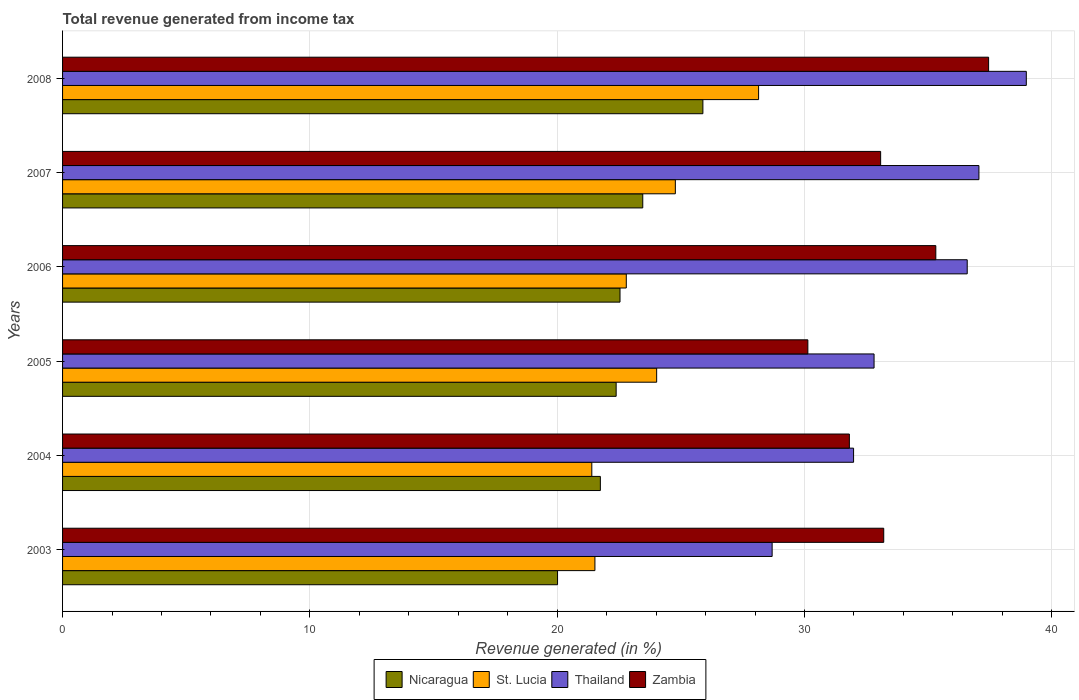How many different coloured bars are there?
Provide a short and direct response. 4. How many groups of bars are there?
Make the answer very short. 6. Are the number of bars per tick equal to the number of legend labels?
Give a very brief answer. Yes. How many bars are there on the 1st tick from the top?
Make the answer very short. 4. How many bars are there on the 6th tick from the bottom?
Provide a succinct answer. 4. What is the label of the 6th group of bars from the top?
Provide a succinct answer. 2003. What is the total revenue generated in St. Lucia in 2004?
Keep it short and to the point. 21.4. Across all years, what is the maximum total revenue generated in Nicaragua?
Provide a succinct answer. 25.89. Across all years, what is the minimum total revenue generated in Thailand?
Provide a short and direct response. 28.69. In which year was the total revenue generated in Zambia minimum?
Keep it short and to the point. 2005. What is the total total revenue generated in Nicaragua in the graph?
Provide a short and direct response. 136.04. What is the difference between the total revenue generated in St. Lucia in 2004 and that in 2008?
Provide a succinct answer. -6.74. What is the difference between the total revenue generated in St. Lucia in 2006 and the total revenue generated in Nicaragua in 2005?
Ensure brevity in your answer.  0.41. What is the average total revenue generated in Thailand per year?
Ensure brevity in your answer.  34.35. In the year 2006, what is the difference between the total revenue generated in Nicaragua and total revenue generated in St. Lucia?
Keep it short and to the point. -0.25. In how many years, is the total revenue generated in Zambia greater than 28 %?
Offer a terse response. 6. What is the ratio of the total revenue generated in Thailand in 2003 to that in 2006?
Offer a terse response. 0.78. What is the difference between the highest and the second highest total revenue generated in Zambia?
Make the answer very short. 2.13. What is the difference between the highest and the lowest total revenue generated in Zambia?
Ensure brevity in your answer.  7.31. Is the sum of the total revenue generated in Zambia in 2005 and 2007 greater than the maximum total revenue generated in St. Lucia across all years?
Keep it short and to the point. Yes. Is it the case that in every year, the sum of the total revenue generated in St. Lucia and total revenue generated in Zambia is greater than the sum of total revenue generated in Nicaragua and total revenue generated in Thailand?
Provide a succinct answer. Yes. What does the 1st bar from the top in 2008 represents?
Offer a very short reply. Zambia. What does the 3rd bar from the bottom in 2008 represents?
Ensure brevity in your answer.  Thailand. Is it the case that in every year, the sum of the total revenue generated in Zambia and total revenue generated in Thailand is greater than the total revenue generated in St. Lucia?
Keep it short and to the point. Yes. How many bars are there?
Provide a succinct answer. 24. What is the difference between two consecutive major ticks on the X-axis?
Make the answer very short. 10. Are the values on the major ticks of X-axis written in scientific E-notation?
Your answer should be very brief. No. Where does the legend appear in the graph?
Give a very brief answer. Bottom center. How many legend labels are there?
Keep it short and to the point. 4. What is the title of the graph?
Keep it short and to the point. Total revenue generated from income tax. Does "Ireland" appear as one of the legend labels in the graph?
Provide a short and direct response. No. What is the label or title of the X-axis?
Offer a terse response. Revenue generated (in %). What is the label or title of the Y-axis?
Provide a short and direct response. Years. What is the Revenue generated (in %) of Nicaragua in 2003?
Make the answer very short. 20.02. What is the Revenue generated (in %) in St. Lucia in 2003?
Offer a terse response. 21.53. What is the Revenue generated (in %) in Thailand in 2003?
Your answer should be compact. 28.69. What is the Revenue generated (in %) of Zambia in 2003?
Your answer should be compact. 33.21. What is the Revenue generated (in %) of Nicaragua in 2004?
Offer a terse response. 21.75. What is the Revenue generated (in %) of St. Lucia in 2004?
Offer a terse response. 21.4. What is the Revenue generated (in %) of Thailand in 2004?
Make the answer very short. 31.99. What is the Revenue generated (in %) of Zambia in 2004?
Give a very brief answer. 31.82. What is the Revenue generated (in %) of Nicaragua in 2005?
Make the answer very short. 22.39. What is the Revenue generated (in %) in St. Lucia in 2005?
Make the answer very short. 24.02. What is the Revenue generated (in %) in Thailand in 2005?
Make the answer very short. 32.81. What is the Revenue generated (in %) in Zambia in 2005?
Offer a terse response. 30.14. What is the Revenue generated (in %) of Nicaragua in 2006?
Keep it short and to the point. 22.54. What is the Revenue generated (in %) of St. Lucia in 2006?
Offer a very short reply. 22.8. What is the Revenue generated (in %) in Thailand in 2006?
Provide a succinct answer. 36.58. What is the Revenue generated (in %) in Zambia in 2006?
Your answer should be very brief. 35.31. What is the Revenue generated (in %) in Nicaragua in 2007?
Your response must be concise. 23.46. What is the Revenue generated (in %) of St. Lucia in 2007?
Make the answer very short. 24.78. What is the Revenue generated (in %) in Thailand in 2007?
Provide a short and direct response. 37.05. What is the Revenue generated (in %) in Zambia in 2007?
Provide a short and direct response. 33.08. What is the Revenue generated (in %) of Nicaragua in 2008?
Your answer should be compact. 25.89. What is the Revenue generated (in %) in St. Lucia in 2008?
Your answer should be compact. 28.15. What is the Revenue generated (in %) in Thailand in 2008?
Give a very brief answer. 38.97. What is the Revenue generated (in %) of Zambia in 2008?
Ensure brevity in your answer.  37.45. Across all years, what is the maximum Revenue generated (in %) in Nicaragua?
Keep it short and to the point. 25.89. Across all years, what is the maximum Revenue generated (in %) in St. Lucia?
Provide a succinct answer. 28.15. Across all years, what is the maximum Revenue generated (in %) of Thailand?
Provide a succinct answer. 38.97. Across all years, what is the maximum Revenue generated (in %) of Zambia?
Your answer should be very brief. 37.45. Across all years, what is the minimum Revenue generated (in %) in Nicaragua?
Provide a succinct answer. 20.02. Across all years, what is the minimum Revenue generated (in %) in St. Lucia?
Ensure brevity in your answer.  21.4. Across all years, what is the minimum Revenue generated (in %) of Thailand?
Keep it short and to the point. 28.69. Across all years, what is the minimum Revenue generated (in %) of Zambia?
Keep it short and to the point. 30.14. What is the total Revenue generated (in %) in Nicaragua in the graph?
Ensure brevity in your answer.  136.04. What is the total Revenue generated (in %) in St. Lucia in the graph?
Offer a terse response. 142.67. What is the total Revenue generated (in %) of Thailand in the graph?
Offer a very short reply. 206.1. What is the total Revenue generated (in %) of Zambia in the graph?
Ensure brevity in your answer.  201. What is the difference between the Revenue generated (in %) of Nicaragua in 2003 and that in 2004?
Ensure brevity in your answer.  -1.73. What is the difference between the Revenue generated (in %) in St. Lucia in 2003 and that in 2004?
Give a very brief answer. 0.13. What is the difference between the Revenue generated (in %) of Thailand in 2003 and that in 2004?
Give a very brief answer. -3.29. What is the difference between the Revenue generated (in %) in Zambia in 2003 and that in 2004?
Your answer should be very brief. 1.39. What is the difference between the Revenue generated (in %) in Nicaragua in 2003 and that in 2005?
Your answer should be very brief. -2.37. What is the difference between the Revenue generated (in %) in St. Lucia in 2003 and that in 2005?
Make the answer very short. -2.5. What is the difference between the Revenue generated (in %) in Thailand in 2003 and that in 2005?
Offer a terse response. -4.12. What is the difference between the Revenue generated (in %) of Zambia in 2003 and that in 2005?
Your answer should be very brief. 3.07. What is the difference between the Revenue generated (in %) in Nicaragua in 2003 and that in 2006?
Give a very brief answer. -2.53. What is the difference between the Revenue generated (in %) of St. Lucia in 2003 and that in 2006?
Your answer should be very brief. -1.27. What is the difference between the Revenue generated (in %) in Thailand in 2003 and that in 2006?
Provide a short and direct response. -7.89. What is the difference between the Revenue generated (in %) in Zambia in 2003 and that in 2006?
Keep it short and to the point. -2.11. What is the difference between the Revenue generated (in %) in Nicaragua in 2003 and that in 2007?
Your answer should be very brief. -3.45. What is the difference between the Revenue generated (in %) of St. Lucia in 2003 and that in 2007?
Your response must be concise. -3.25. What is the difference between the Revenue generated (in %) of Thailand in 2003 and that in 2007?
Provide a succinct answer. -8.36. What is the difference between the Revenue generated (in %) of Zambia in 2003 and that in 2007?
Give a very brief answer. 0.13. What is the difference between the Revenue generated (in %) of Nicaragua in 2003 and that in 2008?
Your answer should be compact. -5.88. What is the difference between the Revenue generated (in %) in St. Lucia in 2003 and that in 2008?
Keep it short and to the point. -6.62. What is the difference between the Revenue generated (in %) in Thailand in 2003 and that in 2008?
Keep it short and to the point. -10.28. What is the difference between the Revenue generated (in %) in Zambia in 2003 and that in 2008?
Give a very brief answer. -4.24. What is the difference between the Revenue generated (in %) in Nicaragua in 2004 and that in 2005?
Your answer should be compact. -0.64. What is the difference between the Revenue generated (in %) of St. Lucia in 2004 and that in 2005?
Offer a terse response. -2.62. What is the difference between the Revenue generated (in %) of Thailand in 2004 and that in 2005?
Make the answer very short. -0.83. What is the difference between the Revenue generated (in %) of Zambia in 2004 and that in 2005?
Offer a very short reply. 1.68. What is the difference between the Revenue generated (in %) of Nicaragua in 2004 and that in 2006?
Make the answer very short. -0.79. What is the difference between the Revenue generated (in %) of St. Lucia in 2004 and that in 2006?
Provide a succinct answer. -1.39. What is the difference between the Revenue generated (in %) of Thailand in 2004 and that in 2006?
Make the answer very short. -4.6. What is the difference between the Revenue generated (in %) of Zambia in 2004 and that in 2006?
Provide a short and direct response. -3.5. What is the difference between the Revenue generated (in %) in Nicaragua in 2004 and that in 2007?
Provide a short and direct response. -1.71. What is the difference between the Revenue generated (in %) of St. Lucia in 2004 and that in 2007?
Your response must be concise. -3.38. What is the difference between the Revenue generated (in %) in Thailand in 2004 and that in 2007?
Provide a short and direct response. -5.07. What is the difference between the Revenue generated (in %) of Zambia in 2004 and that in 2007?
Provide a succinct answer. -1.26. What is the difference between the Revenue generated (in %) of Nicaragua in 2004 and that in 2008?
Offer a very short reply. -4.15. What is the difference between the Revenue generated (in %) of St. Lucia in 2004 and that in 2008?
Keep it short and to the point. -6.74. What is the difference between the Revenue generated (in %) in Thailand in 2004 and that in 2008?
Your answer should be very brief. -6.98. What is the difference between the Revenue generated (in %) in Zambia in 2004 and that in 2008?
Your response must be concise. -5.63. What is the difference between the Revenue generated (in %) in Nicaragua in 2005 and that in 2006?
Give a very brief answer. -0.16. What is the difference between the Revenue generated (in %) of St. Lucia in 2005 and that in 2006?
Make the answer very short. 1.23. What is the difference between the Revenue generated (in %) in Thailand in 2005 and that in 2006?
Provide a short and direct response. -3.77. What is the difference between the Revenue generated (in %) in Zambia in 2005 and that in 2006?
Ensure brevity in your answer.  -5.17. What is the difference between the Revenue generated (in %) of Nicaragua in 2005 and that in 2007?
Provide a short and direct response. -1.08. What is the difference between the Revenue generated (in %) of St. Lucia in 2005 and that in 2007?
Keep it short and to the point. -0.76. What is the difference between the Revenue generated (in %) in Thailand in 2005 and that in 2007?
Make the answer very short. -4.24. What is the difference between the Revenue generated (in %) of Zambia in 2005 and that in 2007?
Ensure brevity in your answer.  -2.94. What is the difference between the Revenue generated (in %) of Nicaragua in 2005 and that in 2008?
Provide a succinct answer. -3.51. What is the difference between the Revenue generated (in %) of St. Lucia in 2005 and that in 2008?
Your answer should be compact. -4.12. What is the difference between the Revenue generated (in %) of Thailand in 2005 and that in 2008?
Your answer should be compact. -6.16. What is the difference between the Revenue generated (in %) in Zambia in 2005 and that in 2008?
Provide a succinct answer. -7.31. What is the difference between the Revenue generated (in %) of Nicaragua in 2006 and that in 2007?
Your response must be concise. -0.92. What is the difference between the Revenue generated (in %) of St. Lucia in 2006 and that in 2007?
Your answer should be very brief. -1.98. What is the difference between the Revenue generated (in %) of Thailand in 2006 and that in 2007?
Offer a terse response. -0.47. What is the difference between the Revenue generated (in %) of Zambia in 2006 and that in 2007?
Ensure brevity in your answer.  2.23. What is the difference between the Revenue generated (in %) in Nicaragua in 2006 and that in 2008?
Provide a short and direct response. -3.35. What is the difference between the Revenue generated (in %) in St. Lucia in 2006 and that in 2008?
Give a very brief answer. -5.35. What is the difference between the Revenue generated (in %) in Thailand in 2006 and that in 2008?
Provide a short and direct response. -2.39. What is the difference between the Revenue generated (in %) in Zambia in 2006 and that in 2008?
Provide a succinct answer. -2.13. What is the difference between the Revenue generated (in %) in Nicaragua in 2007 and that in 2008?
Provide a succinct answer. -2.43. What is the difference between the Revenue generated (in %) of St. Lucia in 2007 and that in 2008?
Make the answer very short. -3.37. What is the difference between the Revenue generated (in %) of Thailand in 2007 and that in 2008?
Offer a very short reply. -1.92. What is the difference between the Revenue generated (in %) in Zambia in 2007 and that in 2008?
Your answer should be compact. -4.37. What is the difference between the Revenue generated (in %) of Nicaragua in 2003 and the Revenue generated (in %) of St. Lucia in 2004?
Provide a succinct answer. -1.39. What is the difference between the Revenue generated (in %) of Nicaragua in 2003 and the Revenue generated (in %) of Thailand in 2004?
Provide a succinct answer. -11.97. What is the difference between the Revenue generated (in %) of Nicaragua in 2003 and the Revenue generated (in %) of Zambia in 2004?
Ensure brevity in your answer.  -11.8. What is the difference between the Revenue generated (in %) in St. Lucia in 2003 and the Revenue generated (in %) in Thailand in 2004?
Your answer should be compact. -10.46. What is the difference between the Revenue generated (in %) of St. Lucia in 2003 and the Revenue generated (in %) of Zambia in 2004?
Your answer should be compact. -10.29. What is the difference between the Revenue generated (in %) of Thailand in 2003 and the Revenue generated (in %) of Zambia in 2004?
Your response must be concise. -3.12. What is the difference between the Revenue generated (in %) of Nicaragua in 2003 and the Revenue generated (in %) of St. Lucia in 2005?
Give a very brief answer. -4.01. What is the difference between the Revenue generated (in %) in Nicaragua in 2003 and the Revenue generated (in %) in Thailand in 2005?
Offer a very short reply. -12.8. What is the difference between the Revenue generated (in %) in Nicaragua in 2003 and the Revenue generated (in %) in Zambia in 2005?
Offer a terse response. -10.12. What is the difference between the Revenue generated (in %) in St. Lucia in 2003 and the Revenue generated (in %) in Thailand in 2005?
Your answer should be compact. -11.29. What is the difference between the Revenue generated (in %) of St. Lucia in 2003 and the Revenue generated (in %) of Zambia in 2005?
Your response must be concise. -8.61. What is the difference between the Revenue generated (in %) of Thailand in 2003 and the Revenue generated (in %) of Zambia in 2005?
Provide a succinct answer. -1.44. What is the difference between the Revenue generated (in %) in Nicaragua in 2003 and the Revenue generated (in %) in St. Lucia in 2006?
Provide a succinct answer. -2.78. What is the difference between the Revenue generated (in %) of Nicaragua in 2003 and the Revenue generated (in %) of Thailand in 2006?
Your response must be concise. -16.57. What is the difference between the Revenue generated (in %) of Nicaragua in 2003 and the Revenue generated (in %) of Zambia in 2006?
Ensure brevity in your answer.  -15.3. What is the difference between the Revenue generated (in %) of St. Lucia in 2003 and the Revenue generated (in %) of Thailand in 2006?
Ensure brevity in your answer.  -15.06. What is the difference between the Revenue generated (in %) of St. Lucia in 2003 and the Revenue generated (in %) of Zambia in 2006?
Keep it short and to the point. -13.79. What is the difference between the Revenue generated (in %) in Thailand in 2003 and the Revenue generated (in %) in Zambia in 2006?
Offer a terse response. -6.62. What is the difference between the Revenue generated (in %) in Nicaragua in 2003 and the Revenue generated (in %) in St. Lucia in 2007?
Provide a short and direct response. -4.76. What is the difference between the Revenue generated (in %) in Nicaragua in 2003 and the Revenue generated (in %) in Thailand in 2007?
Ensure brevity in your answer.  -17.04. What is the difference between the Revenue generated (in %) of Nicaragua in 2003 and the Revenue generated (in %) of Zambia in 2007?
Ensure brevity in your answer.  -13.07. What is the difference between the Revenue generated (in %) of St. Lucia in 2003 and the Revenue generated (in %) of Thailand in 2007?
Give a very brief answer. -15.53. What is the difference between the Revenue generated (in %) in St. Lucia in 2003 and the Revenue generated (in %) in Zambia in 2007?
Offer a very short reply. -11.55. What is the difference between the Revenue generated (in %) of Thailand in 2003 and the Revenue generated (in %) of Zambia in 2007?
Your response must be concise. -4.39. What is the difference between the Revenue generated (in %) of Nicaragua in 2003 and the Revenue generated (in %) of St. Lucia in 2008?
Ensure brevity in your answer.  -8.13. What is the difference between the Revenue generated (in %) of Nicaragua in 2003 and the Revenue generated (in %) of Thailand in 2008?
Offer a terse response. -18.96. What is the difference between the Revenue generated (in %) in Nicaragua in 2003 and the Revenue generated (in %) in Zambia in 2008?
Offer a terse response. -17.43. What is the difference between the Revenue generated (in %) of St. Lucia in 2003 and the Revenue generated (in %) of Thailand in 2008?
Your response must be concise. -17.44. What is the difference between the Revenue generated (in %) in St. Lucia in 2003 and the Revenue generated (in %) in Zambia in 2008?
Your answer should be very brief. -15.92. What is the difference between the Revenue generated (in %) of Thailand in 2003 and the Revenue generated (in %) of Zambia in 2008?
Provide a short and direct response. -8.75. What is the difference between the Revenue generated (in %) in Nicaragua in 2004 and the Revenue generated (in %) in St. Lucia in 2005?
Your answer should be compact. -2.28. What is the difference between the Revenue generated (in %) in Nicaragua in 2004 and the Revenue generated (in %) in Thailand in 2005?
Your answer should be very brief. -11.07. What is the difference between the Revenue generated (in %) of Nicaragua in 2004 and the Revenue generated (in %) of Zambia in 2005?
Offer a very short reply. -8.39. What is the difference between the Revenue generated (in %) of St. Lucia in 2004 and the Revenue generated (in %) of Thailand in 2005?
Provide a succinct answer. -11.41. What is the difference between the Revenue generated (in %) in St. Lucia in 2004 and the Revenue generated (in %) in Zambia in 2005?
Give a very brief answer. -8.74. What is the difference between the Revenue generated (in %) of Thailand in 2004 and the Revenue generated (in %) of Zambia in 2005?
Provide a succinct answer. 1.85. What is the difference between the Revenue generated (in %) of Nicaragua in 2004 and the Revenue generated (in %) of St. Lucia in 2006?
Keep it short and to the point. -1.05. What is the difference between the Revenue generated (in %) of Nicaragua in 2004 and the Revenue generated (in %) of Thailand in 2006?
Offer a very short reply. -14.83. What is the difference between the Revenue generated (in %) of Nicaragua in 2004 and the Revenue generated (in %) of Zambia in 2006?
Offer a terse response. -13.56. What is the difference between the Revenue generated (in %) in St. Lucia in 2004 and the Revenue generated (in %) in Thailand in 2006?
Your answer should be compact. -15.18. What is the difference between the Revenue generated (in %) of St. Lucia in 2004 and the Revenue generated (in %) of Zambia in 2006?
Your answer should be compact. -13.91. What is the difference between the Revenue generated (in %) in Thailand in 2004 and the Revenue generated (in %) in Zambia in 2006?
Your response must be concise. -3.33. What is the difference between the Revenue generated (in %) of Nicaragua in 2004 and the Revenue generated (in %) of St. Lucia in 2007?
Give a very brief answer. -3.03. What is the difference between the Revenue generated (in %) of Nicaragua in 2004 and the Revenue generated (in %) of Thailand in 2007?
Offer a terse response. -15.31. What is the difference between the Revenue generated (in %) of Nicaragua in 2004 and the Revenue generated (in %) of Zambia in 2007?
Ensure brevity in your answer.  -11.33. What is the difference between the Revenue generated (in %) of St. Lucia in 2004 and the Revenue generated (in %) of Thailand in 2007?
Your answer should be compact. -15.65. What is the difference between the Revenue generated (in %) in St. Lucia in 2004 and the Revenue generated (in %) in Zambia in 2007?
Provide a short and direct response. -11.68. What is the difference between the Revenue generated (in %) in Thailand in 2004 and the Revenue generated (in %) in Zambia in 2007?
Your response must be concise. -1.09. What is the difference between the Revenue generated (in %) of Nicaragua in 2004 and the Revenue generated (in %) of St. Lucia in 2008?
Ensure brevity in your answer.  -6.4. What is the difference between the Revenue generated (in %) in Nicaragua in 2004 and the Revenue generated (in %) in Thailand in 2008?
Your response must be concise. -17.22. What is the difference between the Revenue generated (in %) of Nicaragua in 2004 and the Revenue generated (in %) of Zambia in 2008?
Your answer should be compact. -15.7. What is the difference between the Revenue generated (in %) of St. Lucia in 2004 and the Revenue generated (in %) of Thailand in 2008?
Offer a very short reply. -17.57. What is the difference between the Revenue generated (in %) of St. Lucia in 2004 and the Revenue generated (in %) of Zambia in 2008?
Ensure brevity in your answer.  -16.05. What is the difference between the Revenue generated (in %) in Thailand in 2004 and the Revenue generated (in %) in Zambia in 2008?
Give a very brief answer. -5.46. What is the difference between the Revenue generated (in %) in Nicaragua in 2005 and the Revenue generated (in %) in St. Lucia in 2006?
Your answer should be very brief. -0.41. What is the difference between the Revenue generated (in %) of Nicaragua in 2005 and the Revenue generated (in %) of Thailand in 2006?
Provide a short and direct response. -14.2. What is the difference between the Revenue generated (in %) in Nicaragua in 2005 and the Revenue generated (in %) in Zambia in 2006?
Make the answer very short. -12.93. What is the difference between the Revenue generated (in %) of St. Lucia in 2005 and the Revenue generated (in %) of Thailand in 2006?
Your answer should be very brief. -12.56. What is the difference between the Revenue generated (in %) in St. Lucia in 2005 and the Revenue generated (in %) in Zambia in 2006?
Ensure brevity in your answer.  -11.29. What is the difference between the Revenue generated (in %) in Thailand in 2005 and the Revenue generated (in %) in Zambia in 2006?
Give a very brief answer. -2.5. What is the difference between the Revenue generated (in %) in Nicaragua in 2005 and the Revenue generated (in %) in St. Lucia in 2007?
Your answer should be compact. -2.39. What is the difference between the Revenue generated (in %) in Nicaragua in 2005 and the Revenue generated (in %) in Thailand in 2007?
Your response must be concise. -14.67. What is the difference between the Revenue generated (in %) in Nicaragua in 2005 and the Revenue generated (in %) in Zambia in 2007?
Your answer should be very brief. -10.7. What is the difference between the Revenue generated (in %) in St. Lucia in 2005 and the Revenue generated (in %) in Thailand in 2007?
Ensure brevity in your answer.  -13.03. What is the difference between the Revenue generated (in %) in St. Lucia in 2005 and the Revenue generated (in %) in Zambia in 2007?
Your answer should be compact. -9.06. What is the difference between the Revenue generated (in %) in Thailand in 2005 and the Revenue generated (in %) in Zambia in 2007?
Give a very brief answer. -0.27. What is the difference between the Revenue generated (in %) in Nicaragua in 2005 and the Revenue generated (in %) in St. Lucia in 2008?
Your answer should be compact. -5.76. What is the difference between the Revenue generated (in %) in Nicaragua in 2005 and the Revenue generated (in %) in Thailand in 2008?
Give a very brief answer. -16.59. What is the difference between the Revenue generated (in %) of Nicaragua in 2005 and the Revenue generated (in %) of Zambia in 2008?
Provide a succinct answer. -15.06. What is the difference between the Revenue generated (in %) in St. Lucia in 2005 and the Revenue generated (in %) in Thailand in 2008?
Provide a short and direct response. -14.95. What is the difference between the Revenue generated (in %) of St. Lucia in 2005 and the Revenue generated (in %) of Zambia in 2008?
Offer a very short reply. -13.42. What is the difference between the Revenue generated (in %) of Thailand in 2005 and the Revenue generated (in %) of Zambia in 2008?
Make the answer very short. -4.63. What is the difference between the Revenue generated (in %) of Nicaragua in 2006 and the Revenue generated (in %) of St. Lucia in 2007?
Give a very brief answer. -2.24. What is the difference between the Revenue generated (in %) of Nicaragua in 2006 and the Revenue generated (in %) of Thailand in 2007?
Provide a short and direct response. -14.51. What is the difference between the Revenue generated (in %) in Nicaragua in 2006 and the Revenue generated (in %) in Zambia in 2007?
Your answer should be very brief. -10.54. What is the difference between the Revenue generated (in %) of St. Lucia in 2006 and the Revenue generated (in %) of Thailand in 2007?
Offer a terse response. -14.26. What is the difference between the Revenue generated (in %) of St. Lucia in 2006 and the Revenue generated (in %) of Zambia in 2007?
Your response must be concise. -10.28. What is the difference between the Revenue generated (in %) of Thailand in 2006 and the Revenue generated (in %) of Zambia in 2007?
Provide a short and direct response. 3.5. What is the difference between the Revenue generated (in %) of Nicaragua in 2006 and the Revenue generated (in %) of St. Lucia in 2008?
Your response must be concise. -5.6. What is the difference between the Revenue generated (in %) of Nicaragua in 2006 and the Revenue generated (in %) of Thailand in 2008?
Offer a very short reply. -16.43. What is the difference between the Revenue generated (in %) of Nicaragua in 2006 and the Revenue generated (in %) of Zambia in 2008?
Your answer should be compact. -14.9. What is the difference between the Revenue generated (in %) in St. Lucia in 2006 and the Revenue generated (in %) in Thailand in 2008?
Provide a short and direct response. -16.18. What is the difference between the Revenue generated (in %) of St. Lucia in 2006 and the Revenue generated (in %) of Zambia in 2008?
Offer a terse response. -14.65. What is the difference between the Revenue generated (in %) in Thailand in 2006 and the Revenue generated (in %) in Zambia in 2008?
Offer a terse response. -0.86. What is the difference between the Revenue generated (in %) in Nicaragua in 2007 and the Revenue generated (in %) in St. Lucia in 2008?
Your answer should be very brief. -4.68. What is the difference between the Revenue generated (in %) in Nicaragua in 2007 and the Revenue generated (in %) in Thailand in 2008?
Make the answer very short. -15.51. What is the difference between the Revenue generated (in %) of Nicaragua in 2007 and the Revenue generated (in %) of Zambia in 2008?
Provide a short and direct response. -13.98. What is the difference between the Revenue generated (in %) of St. Lucia in 2007 and the Revenue generated (in %) of Thailand in 2008?
Give a very brief answer. -14.19. What is the difference between the Revenue generated (in %) in St. Lucia in 2007 and the Revenue generated (in %) in Zambia in 2008?
Make the answer very short. -12.67. What is the difference between the Revenue generated (in %) in Thailand in 2007 and the Revenue generated (in %) in Zambia in 2008?
Give a very brief answer. -0.39. What is the average Revenue generated (in %) of Nicaragua per year?
Provide a short and direct response. 22.67. What is the average Revenue generated (in %) of St. Lucia per year?
Provide a succinct answer. 23.78. What is the average Revenue generated (in %) in Thailand per year?
Offer a terse response. 34.35. What is the average Revenue generated (in %) of Zambia per year?
Keep it short and to the point. 33.5. In the year 2003, what is the difference between the Revenue generated (in %) of Nicaragua and Revenue generated (in %) of St. Lucia?
Your answer should be very brief. -1.51. In the year 2003, what is the difference between the Revenue generated (in %) in Nicaragua and Revenue generated (in %) in Thailand?
Provide a short and direct response. -8.68. In the year 2003, what is the difference between the Revenue generated (in %) in Nicaragua and Revenue generated (in %) in Zambia?
Provide a succinct answer. -13.19. In the year 2003, what is the difference between the Revenue generated (in %) in St. Lucia and Revenue generated (in %) in Thailand?
Your answer should be very brief. -7.17. In the year 2003, what is the difference between the Revenue generated (in %) of St. Lucia and Revenue generated (in %) of Zambia?
Your answer should be compact. -11.68. In the year 2003, what is the difference between the Revenue generated (in %) of Thailand and Revenue generated (in %) of Zambia?
Give a very brief answer. -4.51. In the year 2004, what is the difference between the Revenue generated (in %) in Nicaragua and Revenue generated (in %) in St. Lucia?
Make the answer very short. 0.35. In the year 2004, what is the difference between the Revenue generated (in %) in Nicaragua and Revenue generated (in %) in Thailand?
Offer a terse response. -10.24. In the year 2004, what is the difference between the Revenue generated (in %) of Nicaragua and Revenue generated (in %) of Zambia?
Keep it short and to the point. -10.07. In the year 2004, what is the difference between the Revenue generated (in %) in St. Lucia and Revenue generated (in %) in Thailand?
Your answer should be very brief. -10.59. In the year 2004, what is the difference between the Revenue generated (in %) in St. Lucia and Revenue generated (in %) in Zambia?
Provide a succinct answer. -10.42. In the year 2004, what is the difference between the Revenue generated (in %) in Thailand and Revenue generated (in %) in Zambia?
Your answer should be compact. 0.17. In the year 2005, what is the difference between the Revenue generated (in %) of Nicaragua and Revenue generated (in %) of St. Lucia?
Keep it short and to the point. -1.64. In the year 2005, what is the difference between the Revenue generated (in %) in Nicaragua and Revenue generated (in %) in Thailand?
Your answer should be compact. -10.43. In the year 2005, what is the difference between the Revenue generated (in %) in Nicaragua and Revenue generated (in %) in Zambia?
Make the answer very short. -7.75. In the year 2005, what is the difference between the Revenue generated (in %) of St. Lucia and Revenue generated (in %) of Thailand?
Ensure brevity in your answer.  -8.79. In the year 2005, what is the difference between the Revenue generated (in %) of St. Lucia and Revenue generated (in %) of Zambia?
Keep it short and to the point. -6.11. In the year 2005, what is the difference between the Revenue generated (in %) in Thailand and Revenue generated (in %) in Zambia?
Your answer should be very brief. 2.68. In the year 2006, what is the difference between the Revenue generated (in %) in Nicaragua and Revenue generated (in %) in St. Lucia?
Give a very brief answer. -0.25. In the year 2006, what is the difference between the Revenue generated (in %) of Nicaragua and Revenue generated (in %) of Thailand?
Provide a succinct answer. -14.04. In the year 2006, what is the difference between the Revenue generated (in %) in Nicaragua and Revenue generated (in %) in Zambia?
Offer a terse response. -12.77. In the year 2006, what is the difference between the Revenue generated (in %) in St. Lucia and Revenue generated (in %) in Thailand?
Your answer should be compact. -13.79. In the year 2006, what is the difference between the Revenue generated (in %) of St. Lucia and Revenue generated (in %) of Zambia?
Offer a very short reply. -12.52. In the year 2006, what is the difference between the Revenue generated (in %) in Thailand and Revenue generated (in %) in Zambia?
Your answer should be compact. 1.27. In the year 2007, what is the difference between the Revenue generated (in %) of Nicaragua and Revenue generated (in %) of St. Lucia?
Give a very brief answer. -1.32. In the year 2007, what is the difference between the Revenue generated (in %) of Nicaragua and Revenue generated (in %) of Thailand?
Keep it short and to the point. -13.59. In the year 2007, what is the difference between the Revenue generated (in %) of Nicaragua and Revenue generated (in %) of Zambia?
Your response must be concise. -9.62. In the year 2007, what is the difference between the Revenue generated (in %) of St. Lucia and Revenue generated (in %) of Thailand?
Make the answer very short. -12.28. In the year 2007, what is the difference between the Revenue generated (in %) in St. Lucia and Revenue generated (in %) in Zambia?
Your answer should be compact. -8.3. In the year 2007, what is the difference between the Revenue generated (in %) in Thailand and Revenue generated (in %) in Zambia?
Make the answer very short. 3.97. In the year 2008, what is the difference between the Revenue generated (in %) in Nicaragua and Revenue generated (in %) in St. Lucia?
Your answer should be compact. -2.25. In the year 2008, what is the difference between the Revenue generated (in %) of Nicaragua and Revenue generated (in %) of Thailand?
Make the answer very short. -13.08. In the year 2008, what is the difference between the Revenue generated (in %) in Nicaragua and Revenue generated (in %) in Zambia?
Make the answer very short. -11.55. In the year 2008, what is the difference between the Revenue generated (in %) of St. Lucia and Revenue generated (in %) of Thailand?
Keep it short and to the point. -10.83. In the year 2008, what is the difference between the Revenue generated (in %) in St. Lucia and Revenue generated (in %) in Zambia?
Provide a succinct answer. -9.3. In the year 2008, what is the difference between the Revenue generated (in %) of Thailand and Revenue generated (in %) of Zambia?
Your answer should be compact. 1.52. What is the ratio of the Revenue generated (in %) of Nicaragua in 2003 to that in 2004?
Provide a short and direct response. 0.92. What is the ratio of the Revenue generated (in %) of St. Lucia in 2003 to that in 2004?
Your answer should be compact. 1.01. What is the ratio of the Revenue generated (in %) in Thailand in 2003 to that in 2004?
Your response must be concise. 0.9. What is the ratio of the Revenue generated (in %) of Zambia in 2003 to that in 2004?
Keep it short and to the point. 1.04. What is the ratio of the Revenue generated (in %) of Nicaragua in 2003 to that in 2005?
Give a very brief answer. 0.89. What is the ratio of the Revenue generated (in %) in St. Lucia in 2003 to that in 2005?
Ensure brevity in your answer.  0.9. What is the ratio of the Revenue generated (in %) in Thailand in 2003 to that in 2005?
Ensure brevity in your answer.  0.87. What is the ratio of the Revenue generated (in %) of Zambia in 2003 to that in 2005?
Your answer should be compact. 1.1. What is the ratio of the Revenue generated (in %) in Nicaragua in 2003 to that in 2006?
Offer a very short reply. 0.89. What is the ratio of the Revenue generated (in %) in St. Lucia in 2003 to that in 2006?
Offer a terse response. 0.94. What is the ratio of the Revenue generated (in %) in Thailand in 2003 to that in 2006?
Your answer should be compact. 0.78. What is the ratio of the Revenue generated (in %) of Zambia in 2003 to that in 2006?
Your response must be concise. 0.94. What is the ratio of the Revenue generated (in %) in Nicaragua in 2003 to that in 2007?
Offer a terse response. 0.85. What is the ratio of the Revenue generated (in %) in St. Lucia in 2003 to that in 2007?
Offer a terse response. 0.87. What is the ratio of the Revenue generated (in %) of Thailand in 2003 to that in 2007?
Offer a very short reply. 0.77. What is the ratio of the Revenue generated (in %) in Nicaragua in 2003 to that in 2008?
Offer a terse response. 0.77. What is the ratio of the Revenue generated (in %) in St. Lucia in 2003 to that in 2008?
Give a very brief answer. 0.76. What is the ratio of the Revenue generated (in %) in Thailand in 2003 to that in 2008?
Your response must be concise. 0.74. What is the ratio of the Revenue generated (in %) of Zambia in 2003 to that in 2008?
Your answer should be compact. 0.89. What is the ratio of the Revenue generated (in %) in Nicaragua in 2004 to that in 2005?
Offer a terse response. 0.97. What is the ratio of the Revenue generated (in %) of St. Lucia in 2004 to that in 2005?
Offer a very short reply. 0.89. What is the ratio of the Revenue generated (in %) in Thailand in 2004 to that in 2005?
Your answer should be compact. 0.97. What is the ratio of the Revenue generated (in %) of Zambia in 2004 to that in 2005?
Make the answer very short. 1.06. What is the ratio of the Revenue generated (in %) in Nicaragua in 2004 to that in 2006?
Your answer should be very brief. 0.96. What is the ratio of the Revenue generated (in %) in St. Lucia in 2004 to that in 2006?
Make the answer very short. 0.94. What is the ratio of the Revenue generated (in %) of Thailand in 2004 to that in 2006?
Ensure brevity in your answer.  0.87. What is the ratio of the Revenue generated (in %) in Zambia in 2004 to that in 2006?
Provide a succinct answer. 0.9. What is the ratio of the Revenue generated (in %) of Nicaragua in 2004 to that in 2007?
Provide a short and direct response. 0.93. What is the ratio of the Revenue generated (in %) of St. Lucia in 2004 to that in 2007?
Your answer should be compact. 0.86. What is the ratio of the Revenue generated (in %) of Thailand in 2004 to that in 2007?
Your answer should be very brief. 0.86. What is the ratio of the Revenue generated (in %) of Zambia in 2004 to that in 2007?
Your answer should be very brief. 0.96. What is the ratio of the Revenue generated (in %) in Nicaragua in 2004 to that in 2008?
Offer a terse response. 0.84. What is the ratio of the Revenue generated (in %) in St. Lucia in 2004 to that in 2008?
Offer a terse response. 0.76. What is the ratio of the Revenue generated (in %) in Thailand in 2004 to that in 2008?
Your answer should be very brief. 0.82. What is the ratio of the Revenue generated (in %) in Zambia in 2004 to that in 2008?
Offer a terse response. 0.85. What is the ratio of the Revenue generated (in %) in Nicaragua in 2005 to that in 2006?
Offer a terse response. 0.99. What is the ratio of the Revenue generated (in %) of St. Lucia in 2005 to that in 2006?
Your answer should be compact. 1.05. What is the ratio of the Revenue generated (in %) in Thailand in 2005 to that in 2006?
Your answer should be very brief. 0.9. What is the ratio of the Revenue generated (in %) in Zambia in 2005 to that in 2006?
Provide a short and direct response. 0.85. What is the ratio of the Revenue generated (in %) of Nicaragua in 2005 to that in 2007?
Provide a short and direct response. 0.95. What is the ratio of the Revenue generated (in %) in St. Lucia in 2005 to that in 2007?
Your answer should be compact. 0.97. What is the ratio of the Revenue generated (in %) in Thailand in 2005 to that in 2007?
Give a very brief answer. 0.89. What is the ratio of the Revenue generated (in %) of Zambia in 2005 to that in 2007?
Offer a terse response. 0.91. What is the ratio of the Revenue generated (in %) of Nicaragua in 2005 to that in 2008?
Your answer should be very brief. 0.86. What is the ratio of the Revenue generated (in %) of St. Lucia in 2005 to that in 2008?
Ensure brevity in your answer.  0.85. What is the ratio of the Revenue generated (in %) in Thailand in 2005 to that in 2008?
Give a very brief answer. 0.84. What is the ratio of the Revenue generated (in %) in Zambia in 2005 to that in 2008?
Ensure brevity in your answer.  0.8. What is the ratio of the Revenue generated (in %) of Nicaragua in 2006 to that in 2007?
Provide a short and direct response. 0.96. What is the ratio of the Revenue generated (in %) of St. Lucia in 2006 to that in 2007?
Your answer should be very brief. 0.92. What is the ratio of the Revenue generated (in %) in Thailand in 2006 to that in 2007?
Your answer should be compact. 0.99. What is the ratio of the Revenue generated (in %) of Zambia in 2006 to that in 2007?
Offer a very short reply. 1.07. What is the ratio of the Revenue generated (in %) in Nicaragua in 2006 to that in 2008?
Offer a very short reply. 0.87. What is the ratio of the Revenue generated (in %) of St. Lucia in 2006 to that in 2008?
Offer a terse response. 0.81. What is the ratio of the Revenue generated (in %) of Thailand in 2006 to that in 2008?
Keep it short and to the point. 0.94. What is the ratio of the Revenue generated (in %) of Zambia in 2006 to that in 2008?
Provide a short and direct response. 0.94. What is the ratio of the Revenue generated (in %) in Nicaragua in 2007 to that in 2008?
Keep it short and to the point. 0.91. What is the ratio of the Revenue generated (in %) in St. Lucia in 2007 to that in 2008?
Provide a short and direct response. 0.88. What is the ratio of the Revenue generated (in %) of Thailand in 2007 to that in 2008?
Make the answer very short. 0.95. What is the ratio of the Revenue generated (in %) of Zambia in 2007 to that in 2008?
Offer a very short reply. 0.88. What is the difference between the highest and the second highest Revenue generated (in %) in Nicaragua?
Give a very brief answer. 2.43. What is the difference between the highest and the second highest Revenue generated (in %) of St. Lucia?
Ensure brevity in your answer.  3.37. What is the difference between the highest and the second highest Revenue generated (in %) in Thailand?
Your response must be concise. 1.92. What is the difference between the highest and the second highest Revenue generated (in %) in Zambia?
Keep it short and to the point. 2.13. What is the difference between the highest and the lowest Revenue generated (in %) of Nicaragua?
Your response must be concise. 5.88. What is the difference between the highest and the lowest Revenue generated (in %) in St. Lucia?
Make the answer very short. 6.74. What is the difference between the highest and the lowest Revenue generated (in %) of Thailand?
Offer a terse response. 10.28. What is the difference between the highest and the lowest Revenue generated (in %) of Zambia?
Ensure brevity in your answer.  7.31. 